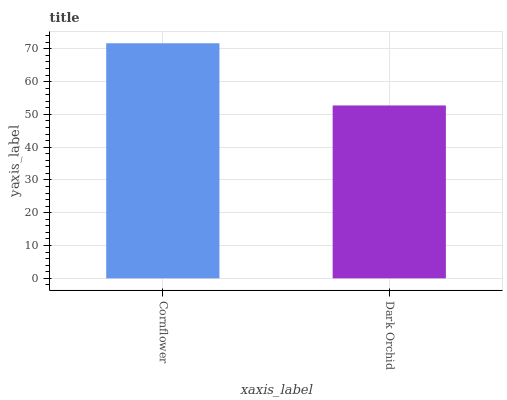Is Dark Orchid the minimum?
Answer yes or no. Yes. Is Cornflower the maximum?
Answer yes or no. Yes. Is Dark Orchid the maximum?
Answer yes or no. No. Is Cornflower greater than Dark Orchid?
Answer yes or no. Yes. Is Dark Orchid less than Cornflower?
Answer yes or no. Yes. Is Dark Orchid greater than Cornflower?
Answer yes or no. No. Is Cornflower less than Dark Orchid?
Answer yes or no. No. Is Cornflower the high median?
Answer yes or no. Yes. Is Dark Orchid the low median?
Answer yes or no. Yes. Is Dark Orchid the high median?
Answer yes or no. No. Is Cornflower the low median?
Answer yes or no. No. 